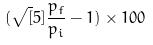<formula> <loc_0><loc_0><loc_500><loc_500>( \sqrt { [ } 5 ] { \frac { p _ { f } } { p _ { i } } } - 1 ) \times 1 0 0</formula> 